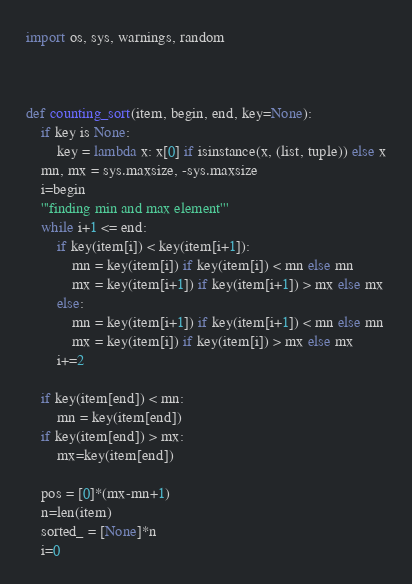<code> <loc_0><loc_0><loc_500><loc_500><_Python_>import os, sys, warnings, random



def counting_sort(item, begin, end, key=None):
    if key is None:
        key = lambda x: x[0] if isinstance(x, (list, tuple)) else x
    mn, mx = sys.maxsize, -sys.maxsize
    i=begin
    '''finding min and max element'''
    while i+1 <= end:
        if key(item[i]) < key(item[i+1]):
            mn = key(item[i]) if key(item[i]) < mn else mn
            mx = key(item[i+1]) if key(item[i+1]) > mx else mx
        else:
            mn = key(item[i+1]) if key(item[i+1]) < mn else mn
            mx = key(item[i]) if key(item[i]) > mx else mx
        i+=2
        
    if key(item[end]) < mn:
        mn = key(item[end])
    if key(item[end]) > mx:
        mx=key(item[end])
            
    pos = [0]*(mx-mn+1)
    n=len(item)
    sorted_ = [None]*n
    i=0</code> 